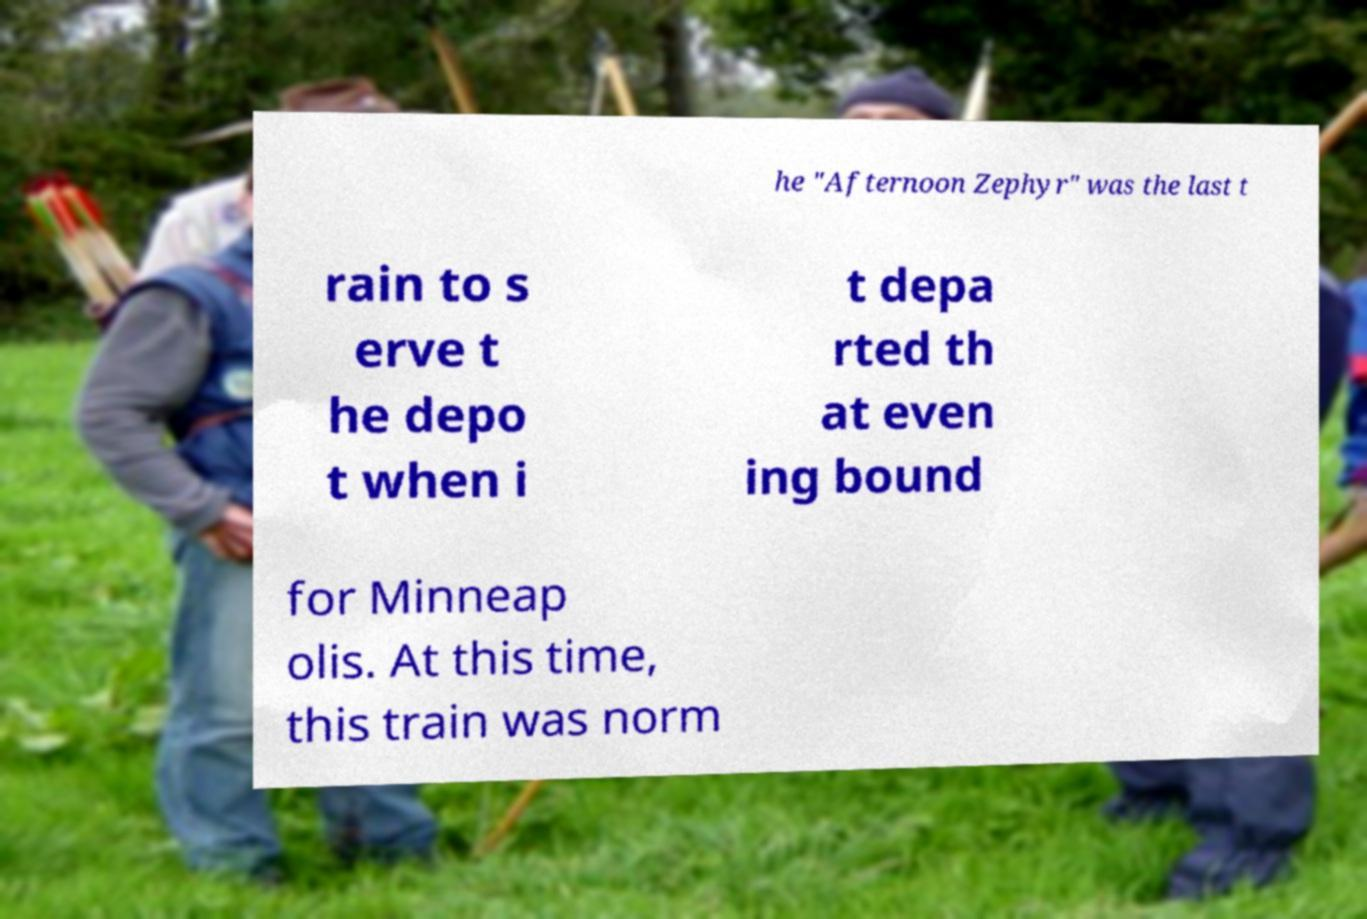Can you read and provide the text displayed in the image?This photo seems to have some interesting text. Can you extract and type it out for me? he "Afternoon Zephyr" was the last t rain to s erve t he depo t when i t depa rted th at even ing bound for Minneap olis. At this time, this train was norm 